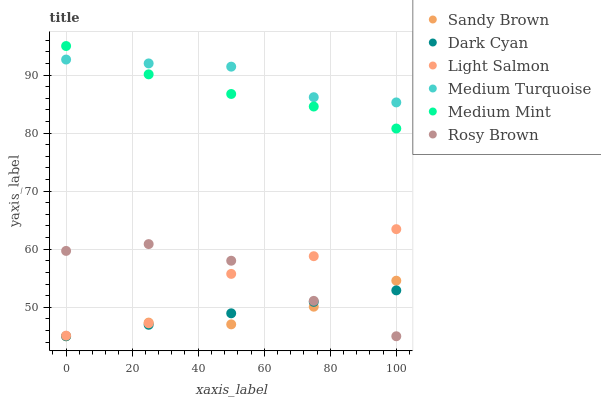Does Sandy Brown have the minimum area under the curve?
Answer yes or no. Yes. Does Medium Turquoise have the maximum area under the curve?
Answer yes or no. Yes. Does Light Salmon have the minimum area under the curve?
Answer yes or no. No. Does Light Salmon have the maximum area under the curve?
Answer yes or no. No. Is Dark Cyan the smoothest?
Answer yes or no. Yes. Is Light Salmon the roughest?
Answer yes or no. Yes. Is Rosy Brown the smoothest?
Answer yes or no. No. Is Rosy Brown the roughest?
Answer yes or no. No. Does Rosy Brown have the lowest value?
Answer yes or no. Yes. Does Light Salmon have the lowest value?
Answer yes or no. No. Does Medium Mint have the highest value?
Answer yes or no. Yes. Does Light Salmon have the highest value?
Answer yes or no. No. Is Rosy Brown less than Medium Mint?
Answer yes or no. Yes. Is Medium Mint greater than Dark Cyan?
Answer yes or no. Yes. Does Light Salmon intersect Sandy Brown?
Answer yes or no. Yes. Is Light Salmon less than Sandy Brown?
Answer yes or no. No. Is Light Salmon greater than Sandy Brown?
Answer yes or no. No. Does Rosy Brown intersect Medium Mint?
Answer yes or no. No. 